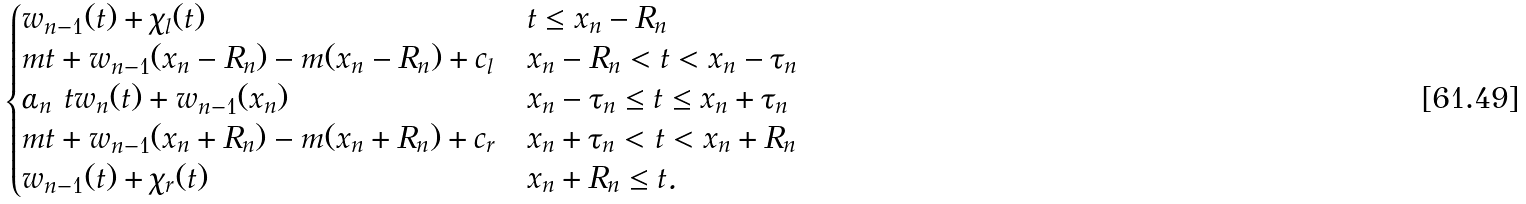<formula> <loc_0><loc_0><loc_500><loc_500>\begin{cases} w _ { n - 1 } ( t ) + \chi _ { l } ( t ) & t \leq x _ { n } - R _ { n } \\ m t + w _ { n - 1 } ( x _ { n } - R _ { n } ) - m ( x _ { n } - R _ { n } ) + c _ { l } & x _ { n } - R _ { n } < t < x _ { n } - \tau _ { n } \\ \alpha _ { n } \ t w _ { n } ( t ) + w _ { n - 1 } ( x _ { n } ) & x _ { n } - \tau _ { n } \leq t \leq x _ { n } + \tau _ { n } \\ m t + w _ { n - 1 } ( x _ { n } + R _ { n } ) - m ( x _ { n } + R _ { n } ) + c _ { r } & x _ { n } + \tau _ { n } < t < x _ { n } + R _ { n } \\ w _ { n - 1 } ( t ) + \chi _ { r } ( t ) & x _ { n } + R _ { n } \leq t . \end{cases}</formula> 